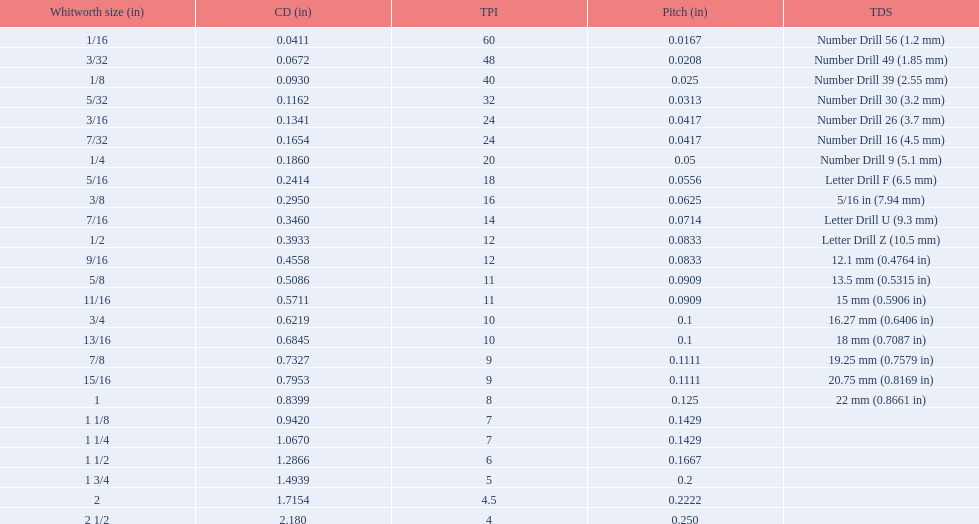What are the standard whitworth sizes in inches? 1/16, 3/32, 1/8, 5/32, 3/16, 7/32, 1/4, 5/16, 3/8, 7/16, 1/2, 9/16, 5/8, 11/16, 3/4, 13/16, 7/8, 15/16, 1, 1 1/8, 1 1/4, 1 1/2, 1 3/4, 2, 2 1/2. How many threads per inch does the 3/16 size have? 24. Which size (in inches) has the same number of threads? 7/32. 